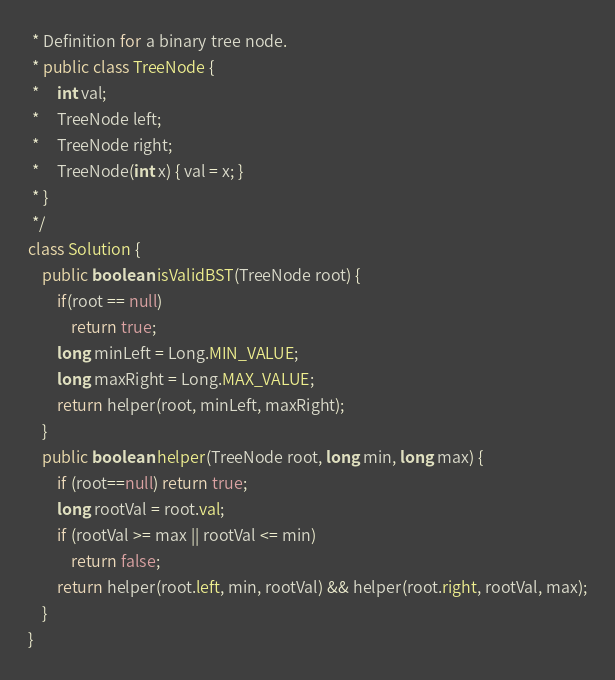Convert code to text. <code><loc_0><loc_0><loc_500><loc_500><_Java_> * Definition for a binary tree node.
 * public class TreeNode {
 *     int val;
 *     TreeNode left;
 *     TreeNode right;
 *     TreeNode(int x) { val = x; }
 * }
 */
class Solution {
    public boolean isValidBST(TreeNode root) {
        if(root == null)
            return true;
        long minLeft = Long.MIN_VALUE;
        long maxRight = Long.MAX_VALUE;
        return helper(root, minLeft, maxRight);
    }
    public boolean helper(TreeNode root, long min, long max) {
        if (root==null) return true;
        long rootVal = root.val;
        if (rootVal >= max || rootVal <= min)
            return false;
        return helper(root.left, min, rootVal) && helper(root.right, rootVal, max);
    }
}
</code> 